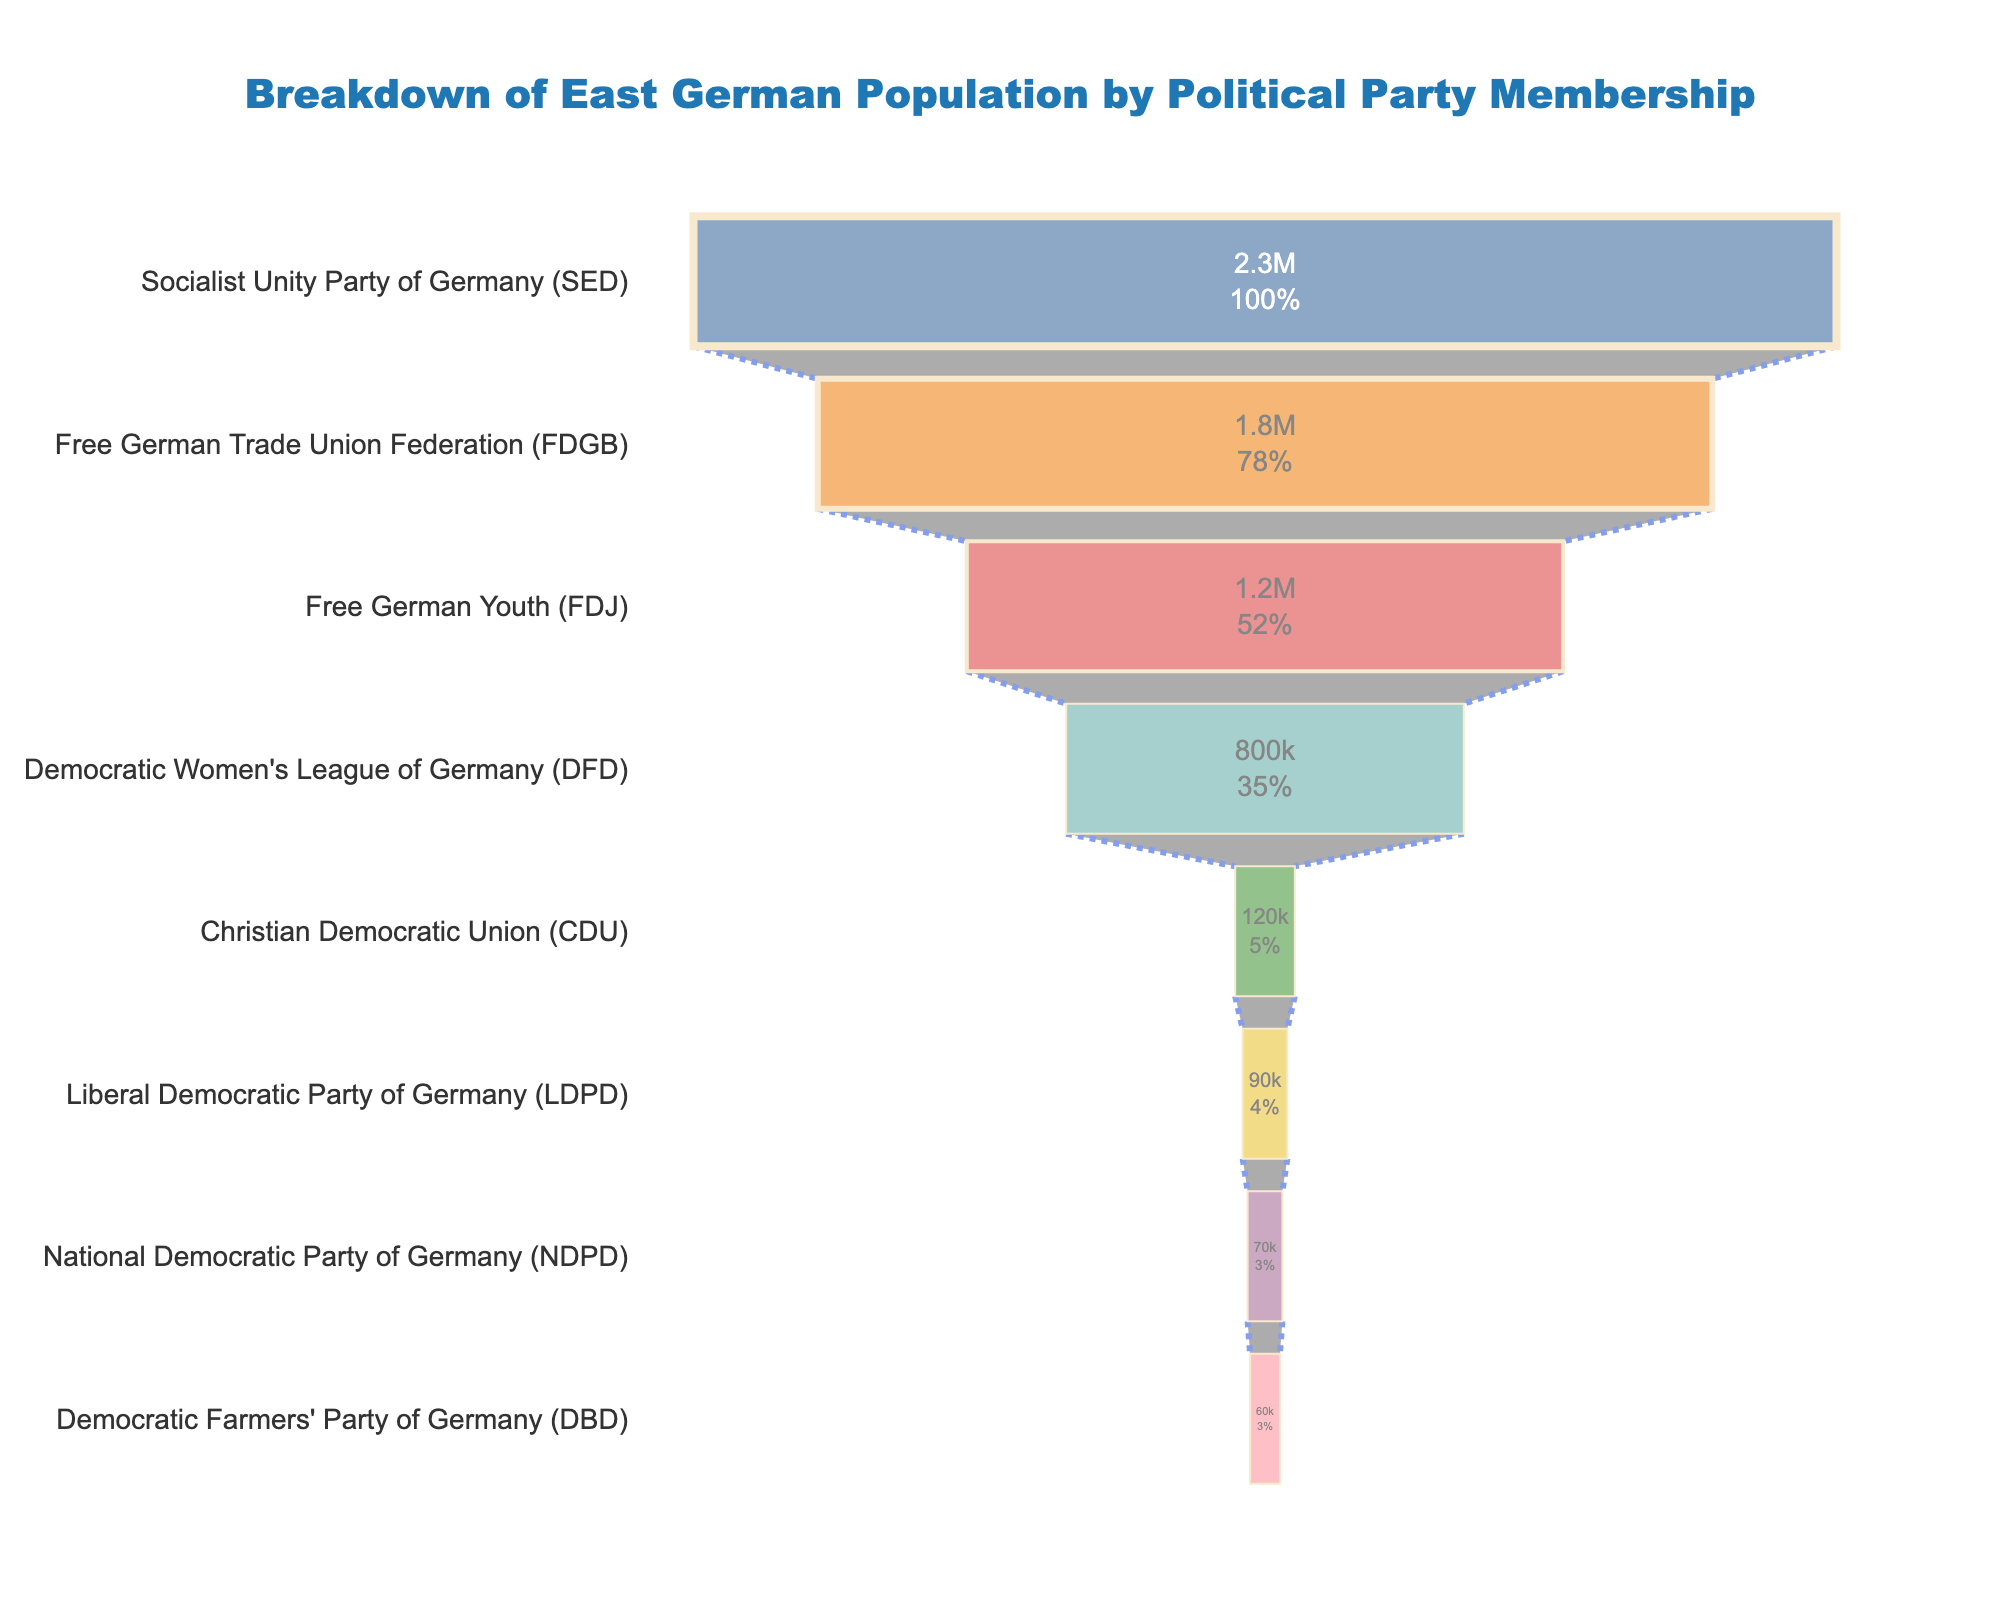What is the total membership count for all parties combined? The total membership count is obtained by summing the members of all parties: 2300000 (SED) + 1800000 (FDGB) + 1200000 (FDJ) + 800000 (DFD) + 120000 (CDU) + 90000 (LDPD) + 70000 (NDPD) + 60000 (DBD). This equals 6400000.
Answer: 6400000 Which party has the highest number of members? The party with the highest number of members is the Socialist Unity Party of Germany (SED) with 2300000 members.
Answer: SED How does the membership of the National Democratic Party of Germany (NDPD) compare to that of the Democratic Farmers' Party of Germany (DBD)? The NDPD has 70000 members, while the DBD has 60000 members. Therefore, the NDPD has 10000 more members compared to the DBD.
Answer: NDPD has 10000 more members What percentage of the initial total does the Free German Youth (FDJ) represent? The FDJ has 1200000 members. To find the percentage of the initial total, we divide 1200000 by the total membership count (6400000) and multiply by 100. This equals (1200000 / 6400000) * 100 = 18.75%.
Answer: 18.75% Which three parties have the lowest membership and what are their counts? The three parties with the lowest membership are the Democratic Farmers' Party of Germany (DBD) with 60000 members, the National Democratic Party of Germany (NDPD) with 70000 members, and the Liberal Democratic Party of Germany (LDPD) with 90000 members.
Answer: DBD: 60000, NDPD: 70000, LDPD: 90000 How many more members does the Socialist Unity Party of Germany (SED) have compared to the Free German Trade Union Federation (FDGB)? The SED has 2300000 members and the FDGB has 1800000 members. The difference is 2300000 - 1800000 = 500000.
Answer: 500000 What is the combined membership of the Christian Democratic Union (CDU) and the Democratic Women's League of Germany (DFD)? The CDU has 120000 members and the DFD has 800000 members. Combined, they have 120000 + 800000 = 920000 members.
Answer: 920000 Which party represents the midpoint in terms of membership numbers in the given funnel chart? To find the midpoint, arrange the parties by membership size: SED (2300000), FDGB (1800000), FDJ (1200000), DFD (800000), CDU (120000), LDPD (90000), NDPD (70000), DBD (60000). The midpoint (4th and 5th positions) are DFD and CDU respectively; thus, CDU represents the midpoint since we are considering the lower median.
Answer: CDU 